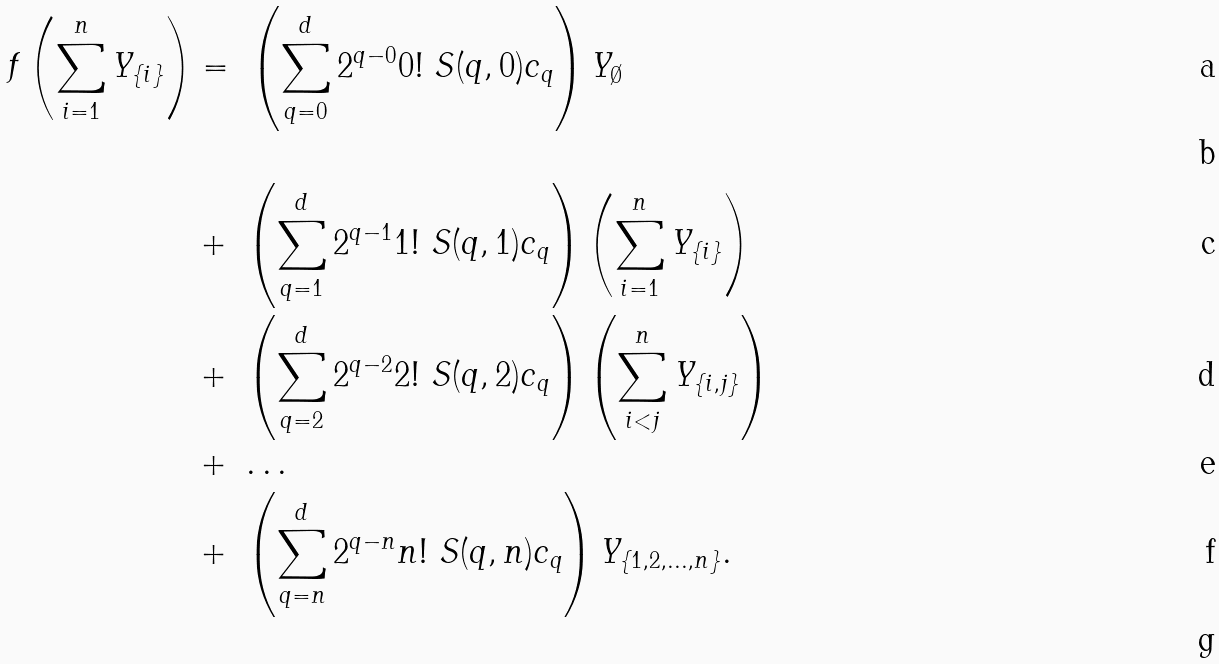Convert formula to latex. <formula><loc_0><loc_0><loc_500><loc_500>f \left ( \sum _ { i = 1 } ^ { n } Y _ { \{ i \} } \right ) & = \ \left ( \sum _ { q = 0 } ^ { d } 2 ^ { q - 0 } 0 ! \ S ( q , 0 ) c _ { q } \right ) Y _ { \emptyset } \\ & \\ & + \ \left ( \sum _ { q = 1 } ^ { d } 2 ^ { q - 1 } 1 ! \ S ( q , 1 ) c _ { q } \right ) \left ( \sum _ { i = 1 } ^ { n } Y _ { \{ i \} } \right ) \\ & + \ \left ( \sum _ { q = 2 } ^ { d } 2 ^ { q - 2 } 2 ! \ S ( q , 2 ) c _ { q } \right ) \left ( \sum _ { i < j } ^ { n } Y _ { \{ i , j \} } \right ) \\ & + \ \dots \\ & + \ \left ( \sum _ { q = n } ^ { d } 2 ^ { q - n } n ! \ S ( q , n ) c _ { q } \right ) Y _ { \{ 1 , 2 , \dots , n \} } . \\</formula> 